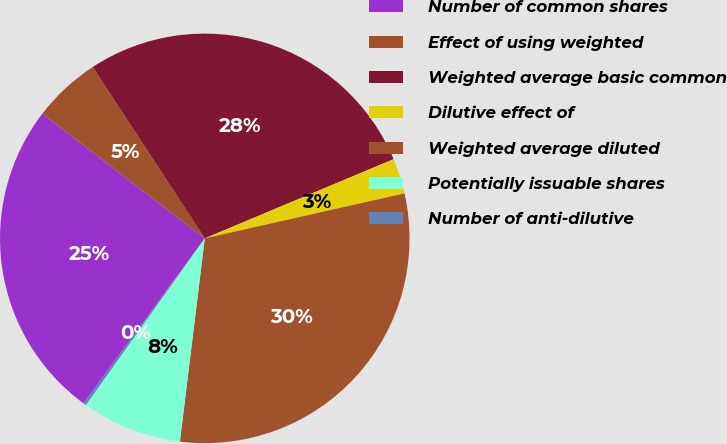Convert chart. <chart><loc_0><loc_0><loc_500><loc_500><pie_chart><fcel>Number of common shares<fcel>Effect of using weighted<fcel>Weighted average basic common<fcel>Dilutive effect of<fcel>Weighted average diluted<fcel>Potentially issuable shares<fcel>Number of anti-dilutive<nl><fcel>25.33%<fcel>5.36%<fcel>27.9%<fcel>2.79%<fcel>30.47%<fcel>7.93%<fcel>0.22%<nl></chart> 